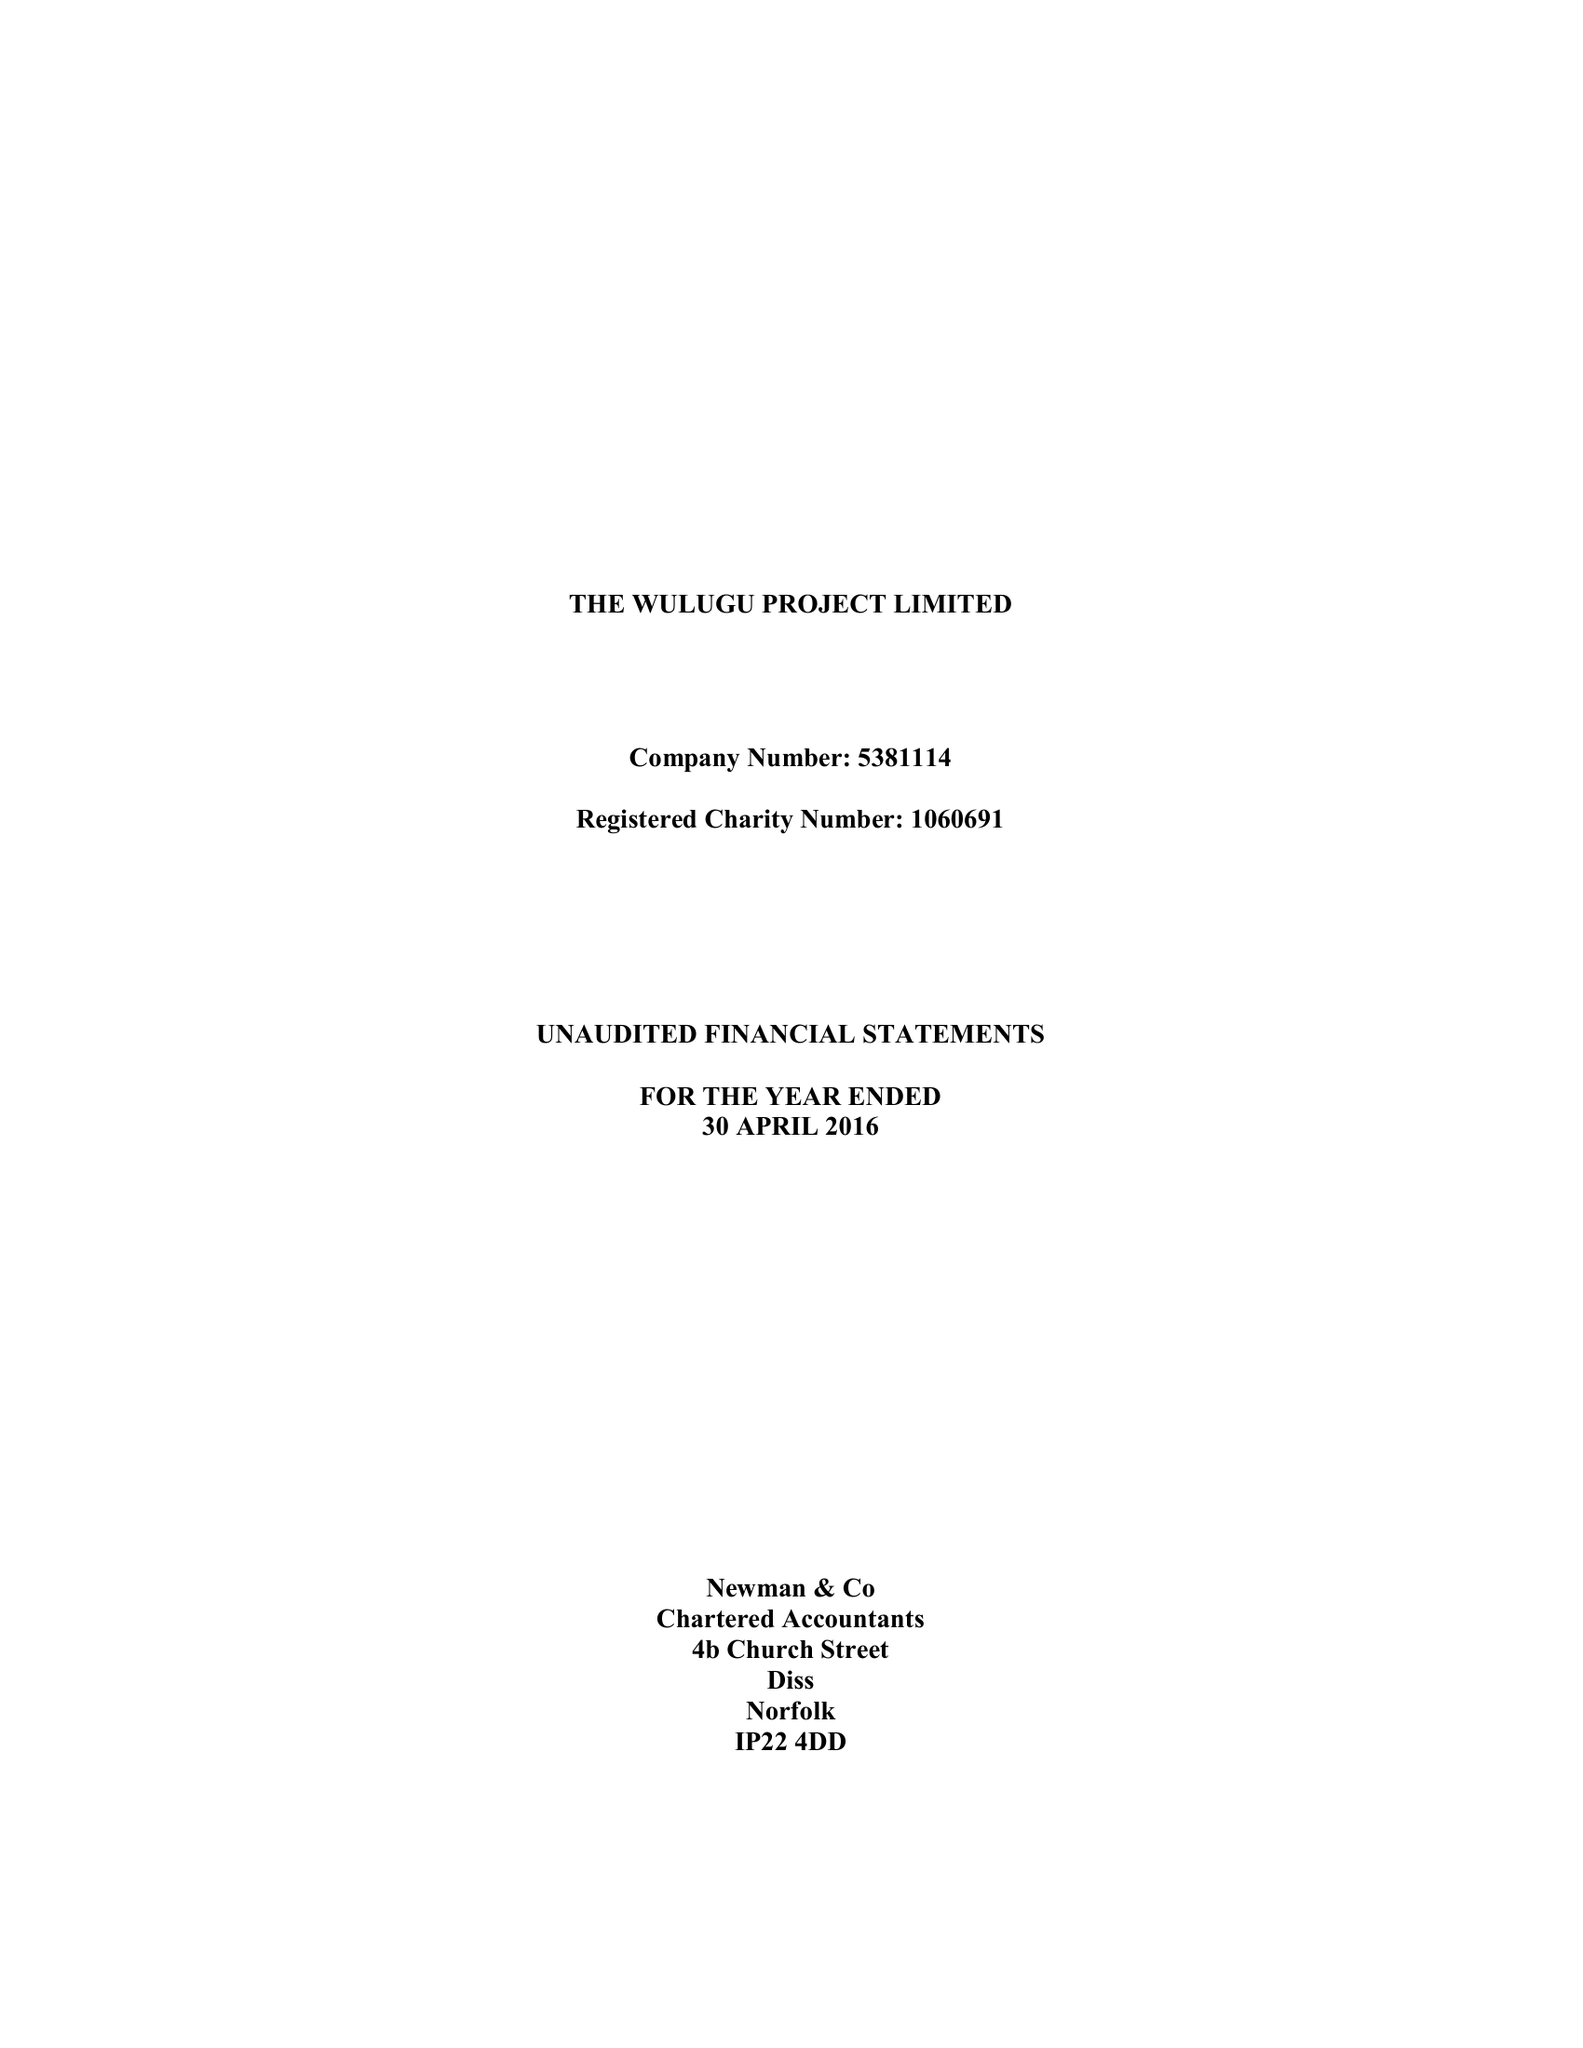What is the value for the address__postcode?
Answer the question using a single word or phrase. NR9 3BH 